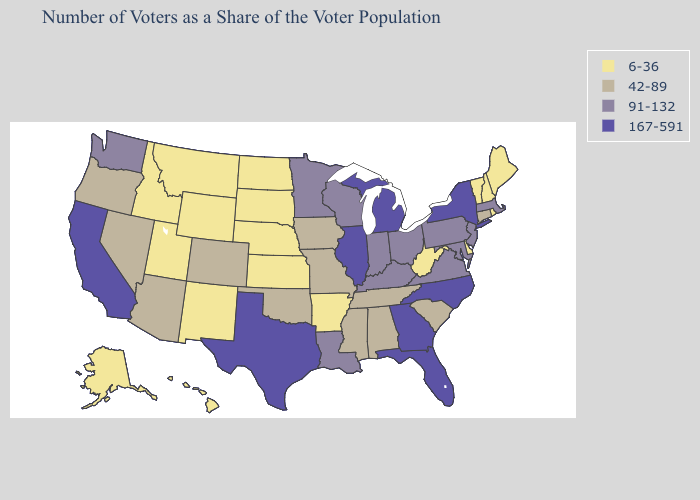Name the states that have a value in the range 167-591?
Write a very short answer. California, Florida, Georgia, Illinois, Michigan, New York, North Carolina, Texas. What is the highest value in states that border Texas?
Give a very brief answer. 91-132. What is the highest value in states that border Massachusetts?
Write a very short answer. 167-591. Does Arkansas have the lowest value in the USA?
Be succinct. Yes. What is the highest value in the USA?
Short answer required. 167-591. What is the value of Maryland?
Give a very brief answer. 91-132. Does Pennsylvania have a lower value than Illinois?
Write a very short answer. Yes. What is the highest value in states that border Wyoming?
Keep it brief. 42-89. What is the value of Georgia?
Short answer required. 167-591. What is the value of Indiana?
Give a very brief answer. 91-132. What is the value of Oregon?
Answer briefly. 42-89. How many symbols are there in the legend?
Keep it brief. 4. What is the highest value in the South ?
Quick response, please. 167-591. Does Indiana have a lower value than Texas?
Write a very short answer. Yes. What is the value of Utah?
Answer briefly. 6-36. 